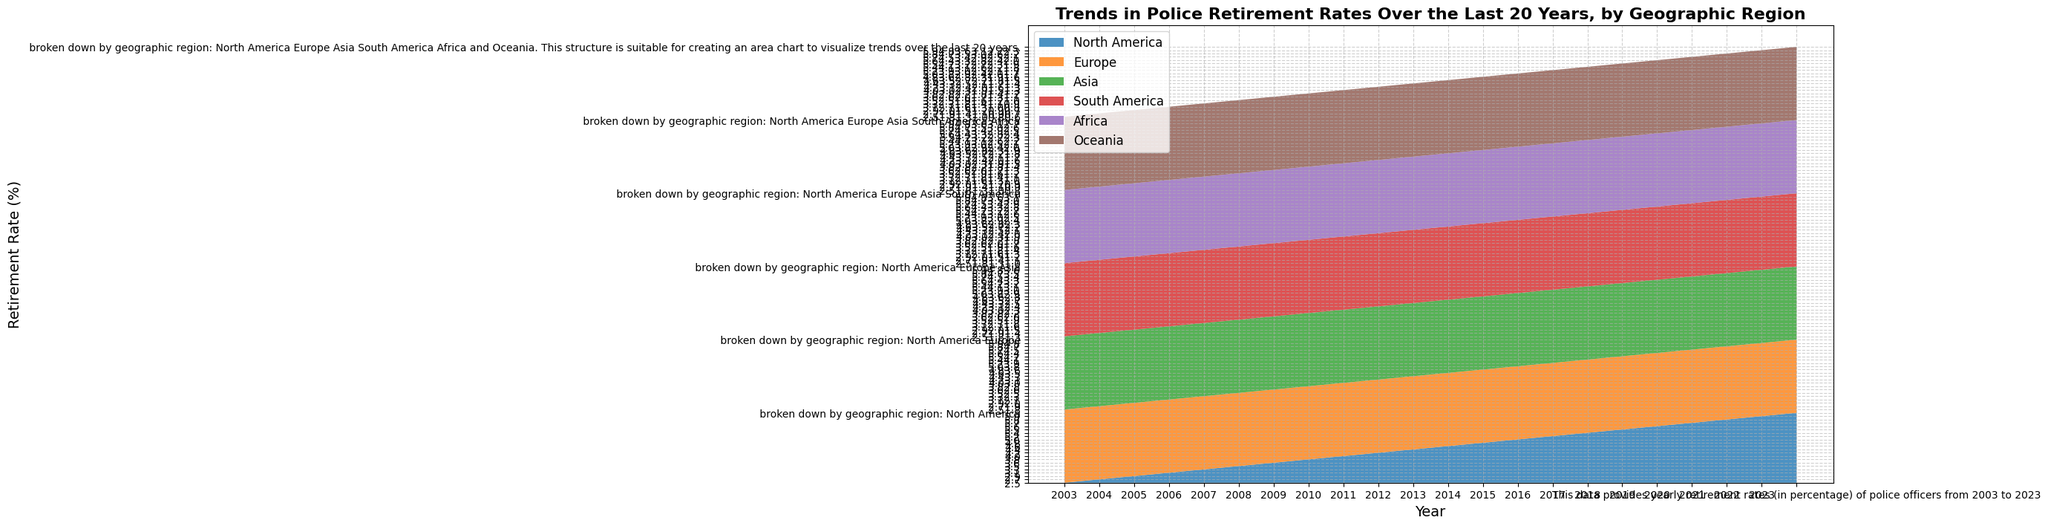What trend can be observed in the retirement rate for North America over the 20-year period? The retirement rate in North America shows a consistent upward trend, starting from 2.5% in 2003 and steadily increasing to 5.9% by 2023.
Answer: Consistent upward trend How does the retirement rate in Europe compare to that in Asia by 2023? By 2023, Europe's retirement rate is 4.8%, which is higher than Asia's rate of 3.6%. A comparison shows that Europe’s rate is 1.2 percentage points higher than Asia’s.
Answer: Europe is higher Which region had the lowest retirement rate in 2003, and what was it? In 2003, Oceania had the lowest retirement rate at 0.6%. This can be observed by comparing the height of each region's area at the starting year.
Answer: Oceania at 0.6% How did the retirement rate in Africa change from 2003 to 2023? In 2003, Africa’s retirement rate was 0.8%. By 2023, it increased to 2.7%. The change over the years can be calculated as 2.7% - 0.8% = 1.9%.
Answer: Increased by 1.9% Which region experienced the most significant increase in retirement rates from 2003 to 2023? North America had the most significant increase, from 2.5% in 2003 to 5.9% in 2023, an increase of 3.4%. This is the highest increase among all regions.
Answer: North America What is the difference in retirement rates between South America and Oceania in the year 2015? In 2015, South America's retirement rate is 2.3%, and Oceania's rate is 1.6%. The difference is 2.3% - 1.6% = 0.7%.
Answer: 0.7% Did any region see a decrease in retirement rates at any point within the given period? No region saw a decrease in retirement rates; all regions show a steady or slightly fluctuating increase over the 20-year period.
Answer: No By what percentage did Europe's retirement rate increase from 2010 to 2020? Europe's retirement rate in 2010 was 2.8%, and in 2020, it was 4.4%. The increase is calculated as (4.4% - 2.8%) / 2.8% * 100% = 57.14%.
Answer: 57.14% What is the combined retirement rate of Europe and Asia in 2022? In 2022, Europe’s retirement rate is 4.7%, and Asia's is 3.5%. The combined rate is 4.7% + 3.5% = 8.2%.
Answer: 8.2% Which region had a retirement rate closest to 3% in 2017 and what was it? In 2017, Asia had a retirement rate closest to 3% at 3.0%. This can be identified by checking the rates for all regions in that year.
Answer: Asia at 3.0% 